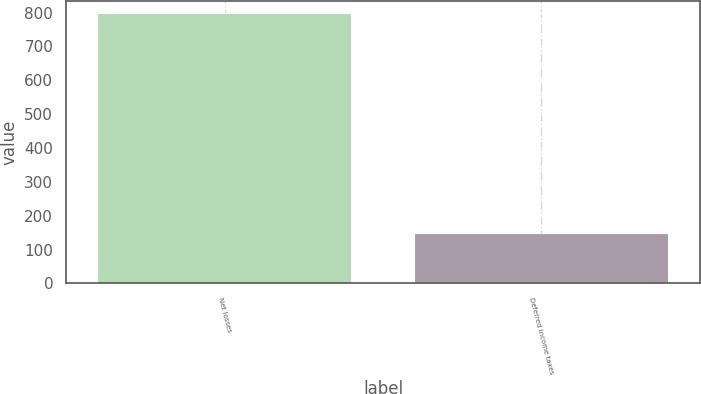<chart> <loc_0><loc_0><loc_500><loc_500><bar_chart><fcel>Net losses<fcel>Deferred income taxes<nl><fcel>796<fcel>146<nl></chart> 